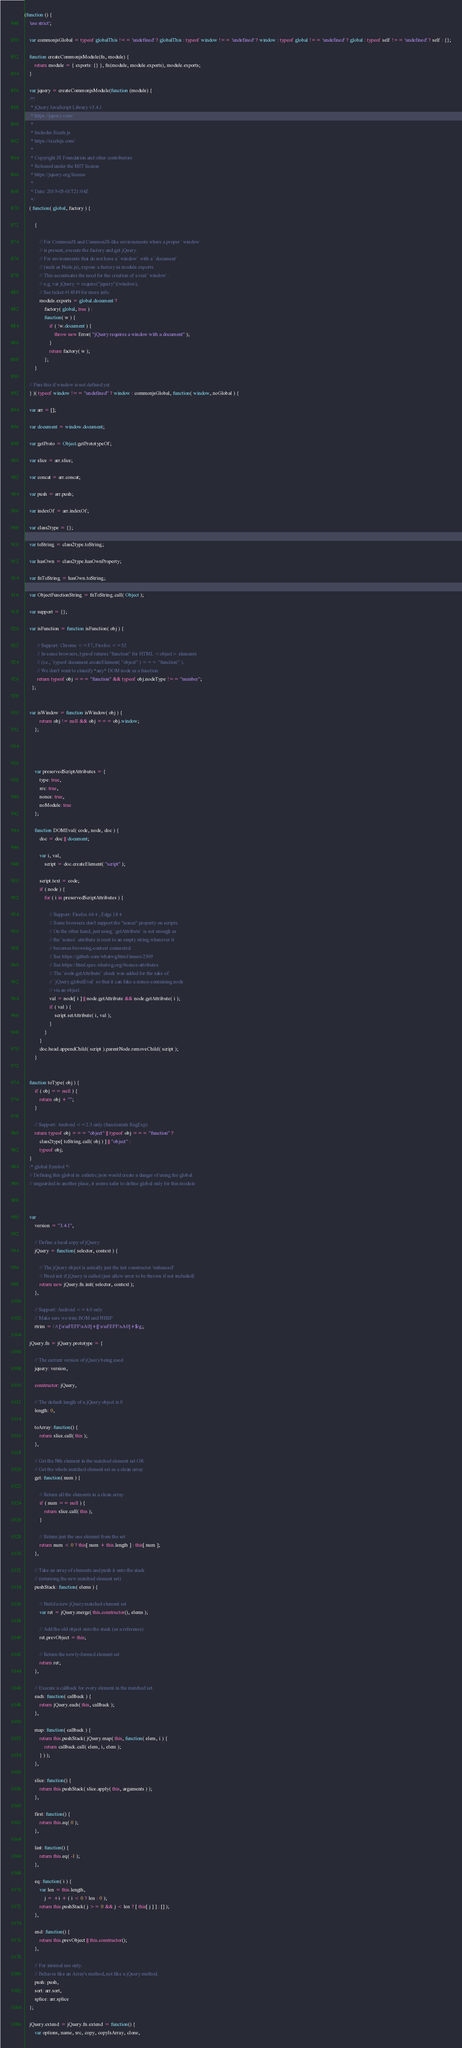Convert code to text. <code><loc_0><loc_0><loc_500><loc_500><_JavaScript_>(function () {
	'use strict';

	var commonjsGlobal = typeof globalThis !== 'undefined' ? globalThis : typeof window !== 'undefined' ? window : typeof global !== 'undefined' ? global : typeof self !== 'undefined' ? self : {};

	function createCommonjsModule(fn, module) {
		return module = { exports: {} }, fn(module, module.exports), module.exports;
	}

	var jquery = createCommonjsModule(function (module) {
	/*!
	 * jQuery JavaScript Library v3.4.1
	 * https://jquery.com/
	 *
	 * Includes Sizzle.js
	 * https://sizzlejs.com/
	 *
	 * Copyright JS Foundation and other contributors
	 * Released under the MIT license
	 * https://jquery.org/license
	 *
	 * Date: 2019-05-01T21:04Z
	 */
	( function( global, factory ) {

		{

			// For CommonJS and CommonJS-like environments where a proper `window`
			// is present, execute the factory and get jQuery.
			// For environments that do not have a `window` with a `document`
			// (such as Node.js), expose a factory as module.exports.
			// This accentuates the need for the creation of a real `window`.
			// e.g. var jQuery = require("jquery")(window);
			// See ticket #14549 for more info.
			module.exports = global.document ?
				factory( global, true ) :
				function( w ) {
					if ( !w.document ) {
						throw new Error( "jQuery requires a window with a document" );
					}
					return factory( w );
				};
		}

	// Pass this if window is not defined yet
	} )( typeof window !== "undefined" ? window : commonjsGlobal, function( window, noGlobal ) {

	var arr = [];

	var document = window.document;

	var getProto = Object.getPrototypeOf;

	var slice = arr.slice;

	var concat = arr.concat;

	var push = arr.push;

	var indexOf = arr.indexOf;

	var class2type = {};

	var toString = class2type.toString;

	var hasOwn = class2type.hasOwnProperty;

	var fnToString = hasOwn.toString;

	var ObjectFunctionString = fnToString.call( Object );

	var support = {};

	var isFunction = function isFunction( obj ) {

	      // Support: Chrome <=57, Firefox <=52
	      // In some browsers, typeof returns "function" for HTML <object> elements
	      // (i.e., `typeof document.createElement( "object" ) === "function"`).
	      // We don't want to classify *any* DOM node as a function.
	      return typeof obj === "function" && typeof obj.nodeType !== "number";
	  };


	var isWindow = function isWindow( obj ) {
			return obj != null && obj === obj.window;
		};




		var preservedScriptAttributes = {
			type: true,
			src: true,
			nonce: true,
			noModule: true
		};

		function DOMEval( code, node, doc ) {
			doc = doc || document;

			var i, val,
				script = doc.createElement( "script" );

			script.text = code;
			if ( node ) {
				for ( i in preservedScriptAttributes ) {

					// Support: Firefox 64+, Edge 18+
					// Some browsers don't support the "nonce" property on scripts.
					// On the other hand, just using `getAttribute` is not enough as
					// the `nonce` attribute is reset to an empty string whenever it
					// becomes browsing-context connected.
					// See https://github.com/whatwg/html/issues/2369
					// See https://html.spec.whatwg.org/#nonce-attributes
					// The `node.getAttribute` check was added for the sake of
					// `jQuery.globalEval` so that it can fake a nonce-containing node
					// via an object.
					val = node[ i ] || node.getAttribute && node.getAttribute( i );
					if ( val ) {
						script.setAttribute( i, val );
					}
				}
			}
			doc.head.appendChild( script ).parentNode.removeChild( script );
		}


	function toType( obj ) {
		if ( obj == null ) {
			return obj + "";
		}

		// Support: Android <=2.3 only (functionish RegExp)
		return typeof obj === "object" || typeof obj === "function" ?
			class2type[ toString.call( obj ) ] || "object" :
			typeof obj;
	}
	/* global Symbol */
	// Defining this global in .eslintrc.json would create a danger of using the global
	// unguarded in another place, it seems safer to define global only for this module



	var
		version = "3.4.1",

		// Define a local copy of jQuery
		jQuery = function( selector, context ) {

			// The jQuery object is actually just the init constructor 'enhanced'
			// Need init if jQuery is called (just allow error to be thrown if not included)
			return new jQuery.fn.init( selector, context );
		},

		// Support: Android <=4.0 only
		// Make sure we trim BOM and NBSP
		rtrim = /^[\s\uFEFF\xA0]+|[\s\uFEFF\xA0]+$/g;

	jQuery.fn = jQuery.prototype = {

		// The current version of jQuery being used
		jquery: version,

		constructor: jQuery,

		// The default length of a jQuery object is 0
		length: 0,

		toArray: function() {
			return slice.call( this );
		},

		// Get the Nth element in the matched element set OR
		// Get the whole matched element set as a clean array
		get: function( num ) {

			// Return all the elements in a clean array
			if ( num == null ) {
				return slice.call( this );
			}

			// Return just the one element from the set
			return num < 0 ? this[ num + this.length ] : this[ num ];
		},

		// Take an array of elements and push it onto the stack
		// (returning the new matched element set)
		pushStack: function( elems ) {

			// Build a new jQuery matched element set
			var ret = jQuery.merge( this.constructor(), elems );

			// Add the old object onto the stack (as a reference)
			ret.prevObject = this;

			// Return the newly-formed element set
			return ret;
		},

		// Execute a callback for every element in the matched set.
		each: function( callback ) {
			return jQuery.each( this, callback );
		},

		map: function( callback ) {
			return this.pushStack( jQuery.map( this, function( elem, i ) {
				return callback.call( elem, i, elem );
			} ) );
		},

		slice: function() {
			return this.pushStack( slice.apply( this, arguments ) );
		},

		first: function() {
			return this.eq( 0 );
		},

		last: function() {
			return this.eq( -1 );
		},

		eq: function( i ) {
			var len = this.length,
				j = +i + ( i < 0 ? len : 0 );
			return this.pushStack( j >= 0 && j < len ? [ this[ j ] ] : [] );
		},

		end: function() {
			return this.prevObject || this.constructor();
		},

		// For internal use only.
		// Behaves like an Array's method, not like a jQuery method.
		push: push,
		sort: arr.sort,
		splice: arr.splice
	};

	jQuery.extend = jQuery.fn.extend = function() {
		var options, name, src, copy, copyIsArray, clone,</code> 